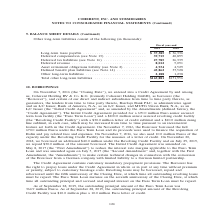According to Coherent's financial document, What was Long-term taxes payable in 2019? According to the financial document, $37,385 (in thousands). The relevant text states: "Long-term taxes payable . $ 37,385 $ 36,336 Deferred compensation (see Note 13) . 39,715 40,895 Deferred tax liabilities (see Note 16)..." Also, What was  Total other long-term liabilities  in 2018? According to the financial document, $151,956 (in thousands). The relevant text states: "Total other long-term liabilities . $165,881 $151,956..." Also, In which years were long-term liabilities calculated? The document shows two values: 2019 and 2018. From the document: "Fiscal year-end 2019 2018 Fiscal year-end 2019 2018..." Additionally, In which year was Other long-term liabilities larger? According to the financial document, 2019. The relevant text states: "Fiscal year-end 2019 2018..." Also, can you calculate: What was the change in Other long-term liabilities from 2018 to 2019? Based on the calculation: 2,188-1,238, the result is 950 (in thousands). This is based on the information: "45,862 37,528 Other long-term liabilities . 2,188 1,238 14) . 45,862 37,528 Other long-term liabilities . 2,188 1,238..." The key data points involved are: 1,238, 2,188. Also, can you calculate: What was the percentage change in Other long-term liabilities from 2018 to 2019? To answer this question, I need to perform calculations using the financial data. The calculation is: (2,188-1,238)/1,238, which equals 76.74 (percentage). This is based on the information: "45,862 37,528 Other long-term liabilities . 2,188 1,238 14) . 45,862 37,528 Other long-term liabilities . 2,188 1,238..." The key data points involved are: 1,238, 2,188. 